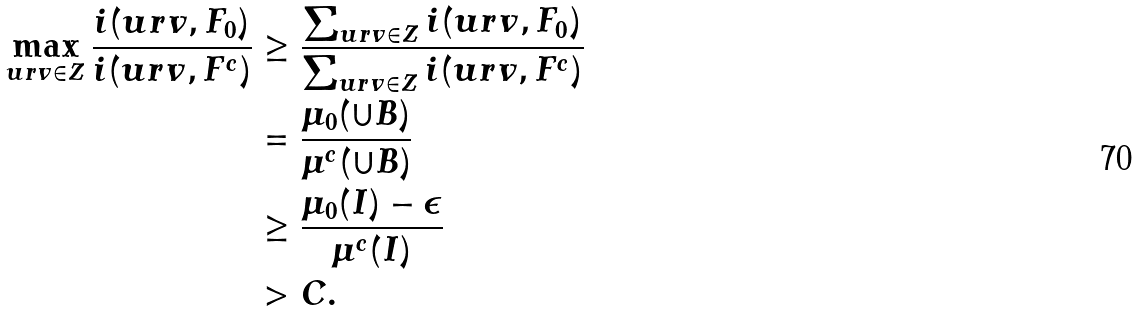Convert formula to latex. <formula><loc_0><loc_0><loc_500><loc_500>\max _ { u r v \in Z } \frac { i ( u r v , F _ { 0 } ) } { i ( u r v , F ^ { c } ) } & \geq \frac { \sum _ { u r v \in Z } i ( u r v , F _ { 0 } ) } { \sum _ { u r v \in Z } i ( u r v , F ^ { c } ) } \\ & = \frac { \mu _ { 0 } ( \cup B ) } { \mu ^ { c } ( \cup B ) } \\ & \geq \frac { \mu _ { 0 } ( I ) - \epsilon } { \mu ^ { c } ( I ) } \\ & > C .</formula> 